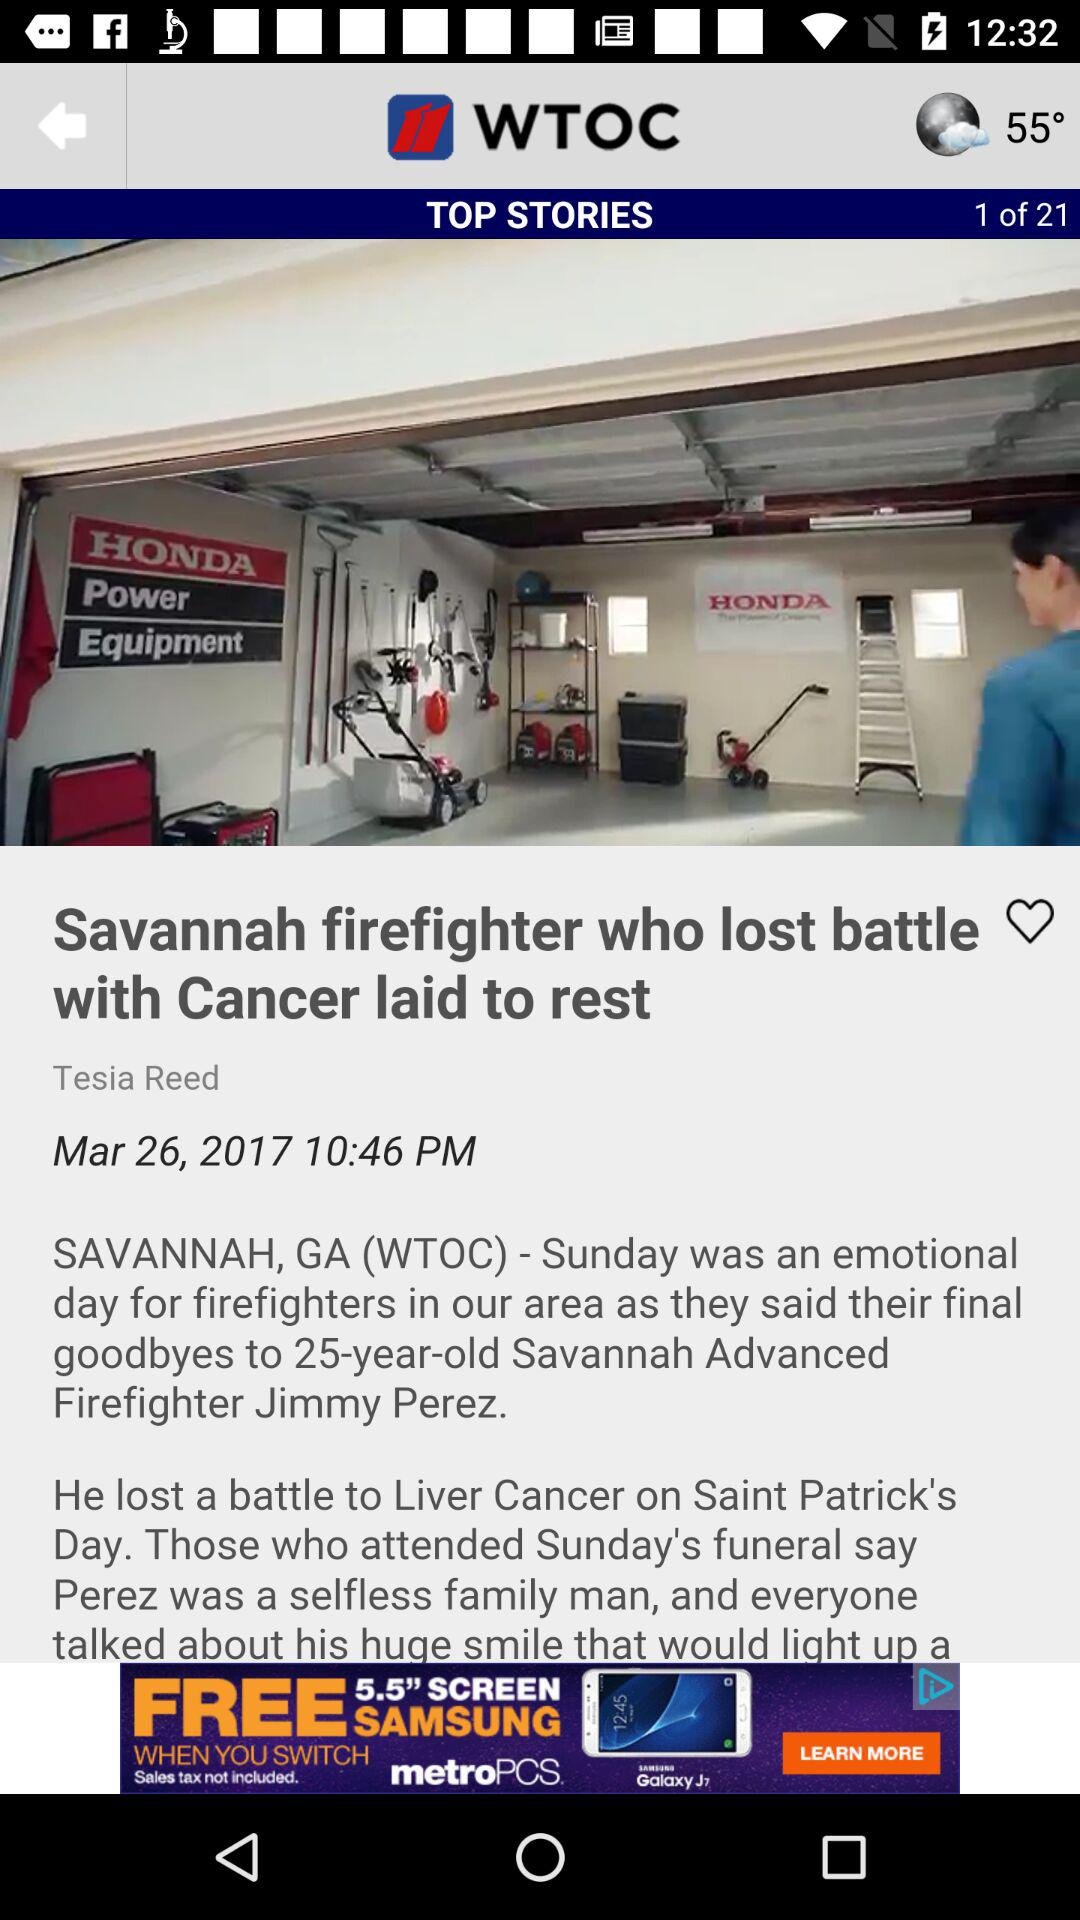What is the total number of pages? The total number of pages is 21. 